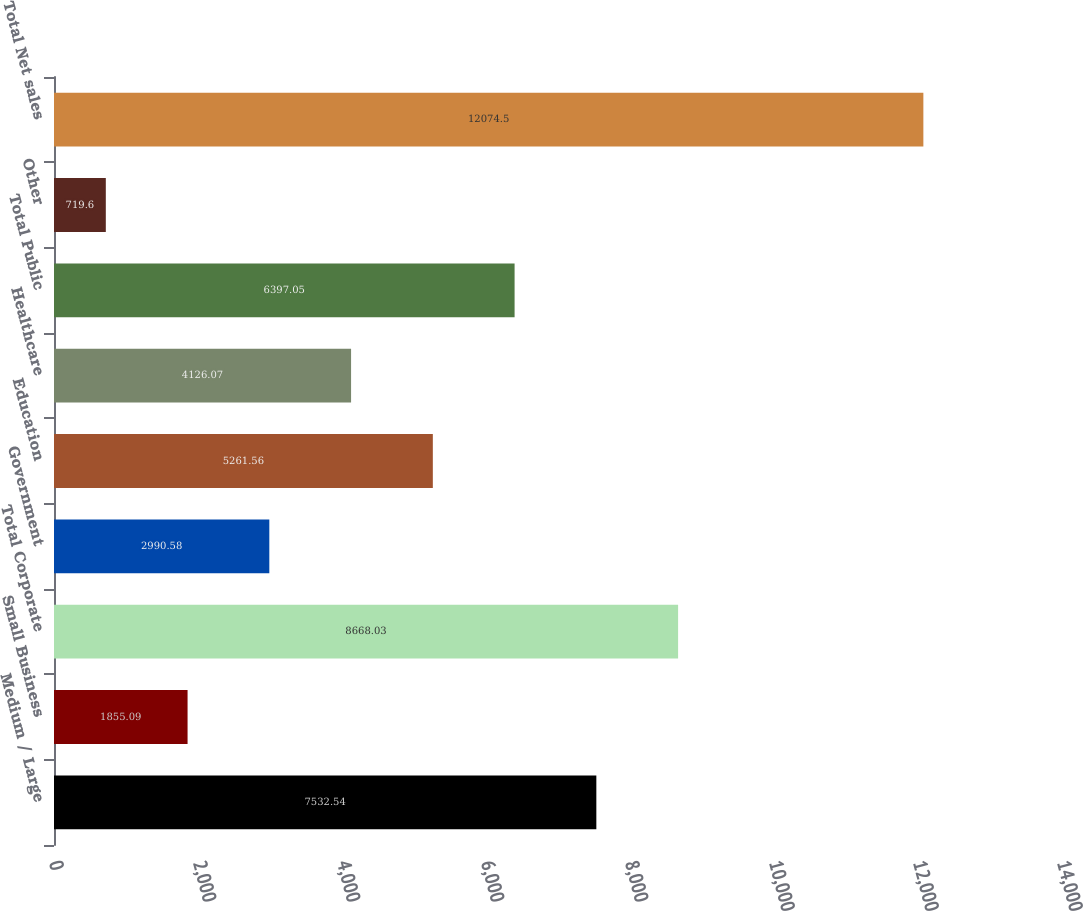<chart> <loc_0><loc_0><loc_500><loc_500><bar_chart><fcel>Medium / Large<fcel>Small Business<fcel>Total Corporate<fcel>Government<fcel>Education<fcel>Healthcare<fcel>Total Public<fcel>Other<fcel>Total Net sales<nl><fcel>7532.54<fcel>1855.09<fcel>8668.03<fcel>2990.58<fcel>5261.56<fcel>4126.07<fcel>6397.05<fcel>719.6<fcel>12074.5<nl></chart> 